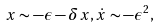Convert formula to latex. <formula><loc_0><loc_0><loc_500><loc_500>x \sim - \epsilon - \delta x , \dot { x } \sim - \epsilon ^ { 2 } ,</formula> 